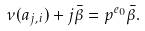<formula> <loc_0><loc_0><loc_500><loc_500>\nu ( a _ { j , i } ) + j \bar { \beta } = p ^ { e _ { 0 } } \bar { \beta } .</formula> 